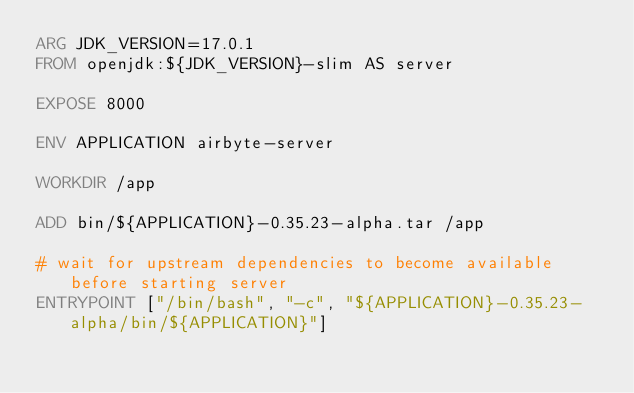Convert code to text. <code><loc_0><loc_0><loc_500><loc_500><_Dockerfile_>ARG JDK_VERSION=17.0.1
FROM openjdk:${JDK_VERSION}-slim AS server

EXPOSE 8000

ENV APPLICATION airbyte-server

WORKDIR /app

ADD bin/${APPLICATION}-0.35.23-alpha.tar /app

# wait for upstream dependencies to become available before starting server
ENTRYPOINT ["/bin/bash", "-c", "${APPLICATION}-0.35.23-alpha/bin/${APPLICATION}"]
</code> 